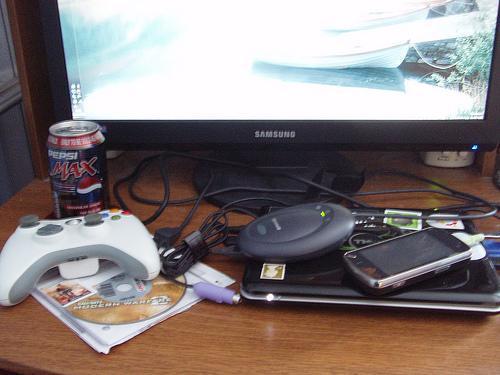How many buttons are on the controller?
Give a very brief answer. 8. How many computers in total?
Give a very brief answer. 2. 